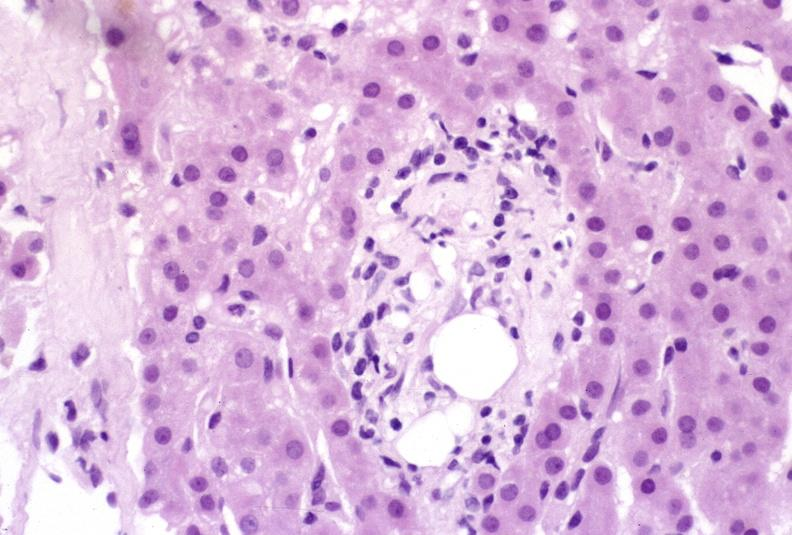does previous slide from this case show ductopenia?
Answer the question using a single word or phrase. No 